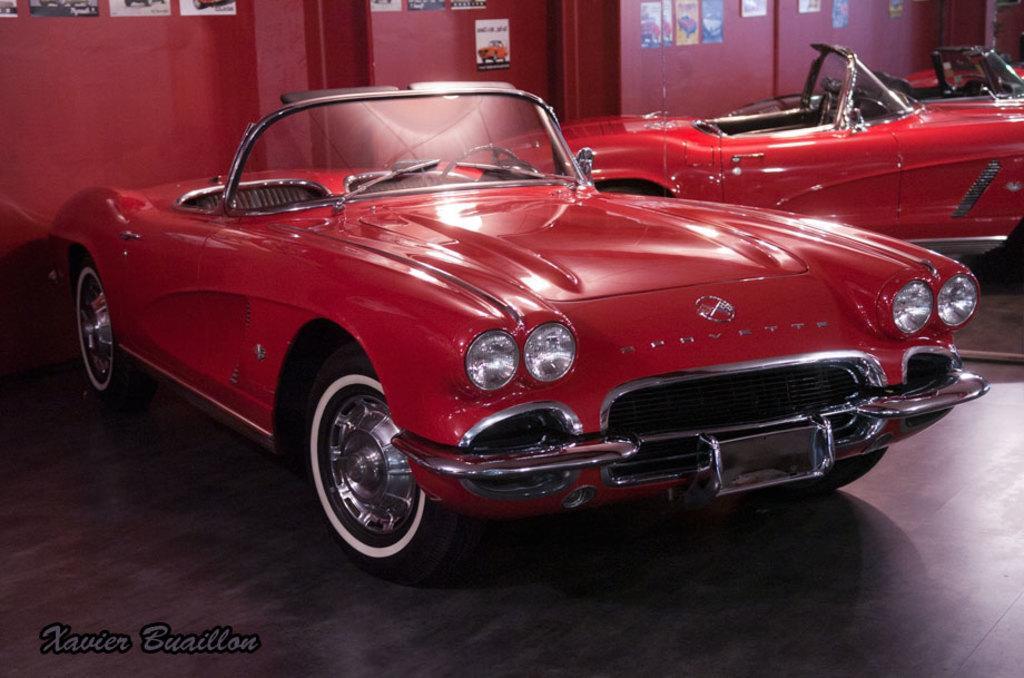In one or two sentences, can you explain what this image depicts? In the center of the image there is a car on the floor. in the background we can see mirror, wall and posters. At the bottom there is text. 